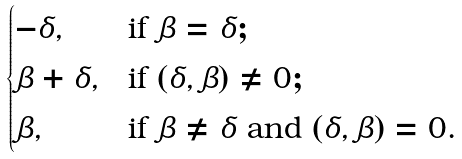Convert formula to latex. <formula><loc_0><loc_0><loc_500><loc_500>\begin{cases} - \delta , & \text {if } \beta = \delta ; \\ \beta + \delta , & \text {if } ( \delta , \beta ) \neq 0 ; \\ \beta , & \text {if } \beta \neq \delta \text { and } ( \delta , \beta ) = 0 . \end{cases}</formula> 